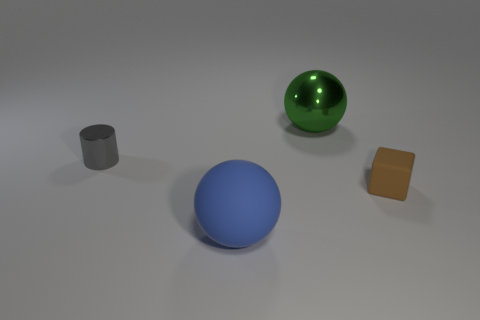Add 1 small purple metal things. How many objects exist? 5 Subtract 1 cylinders. How many cylinders are left? 0 Subtract all blocks. How many objects are left? 3 Subtract all large red metallic cylinders. Subtract all green spheres. How many objects are left? 3 Add 4 gray metal things. How many gray metal things are left? 5 Add 4 red metal cubes. How many red metal cubes exist? 4 Subtract 1 gray cylinders. How many objects are left? 3 Subtract all cyan cubes. Subtract all cyan cylinders. How many cubes are left? 1 